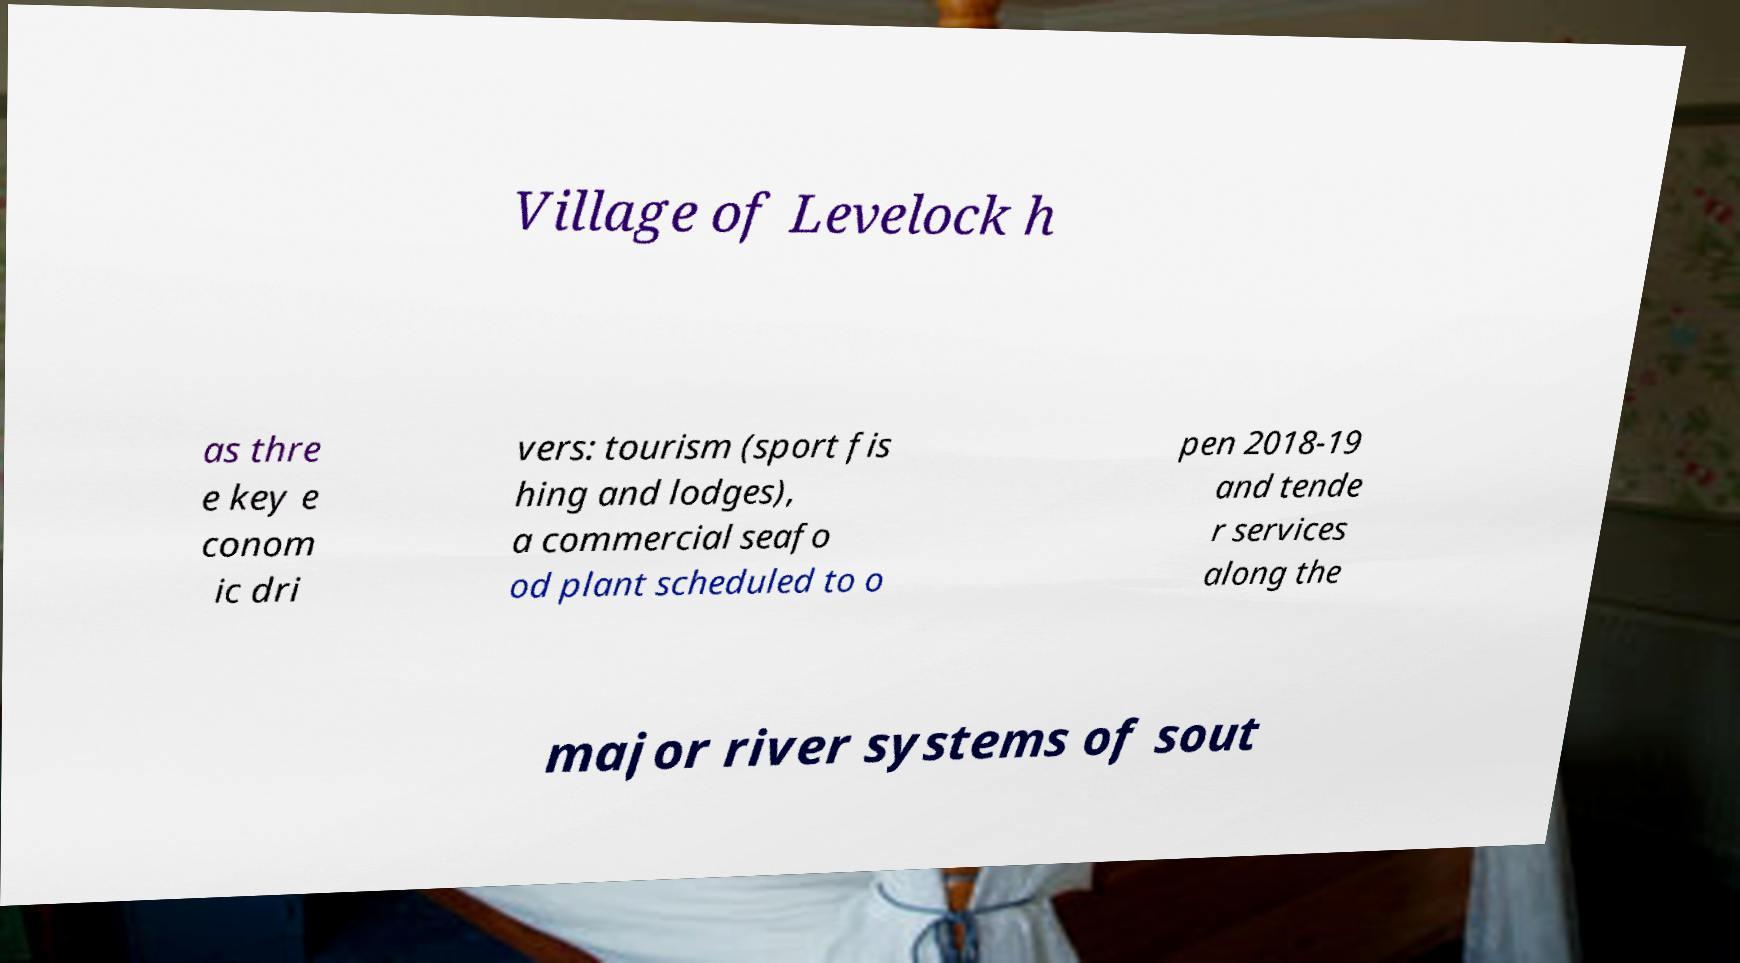Could you extract and type out the text from this image? Village of Levelock h as thre e key e conom ic dri vers: tourism (sport fis hing and lodges), a commercial seafo od plant scheduled to o pen 2018-19 and tende r services along the major river systems of sout 